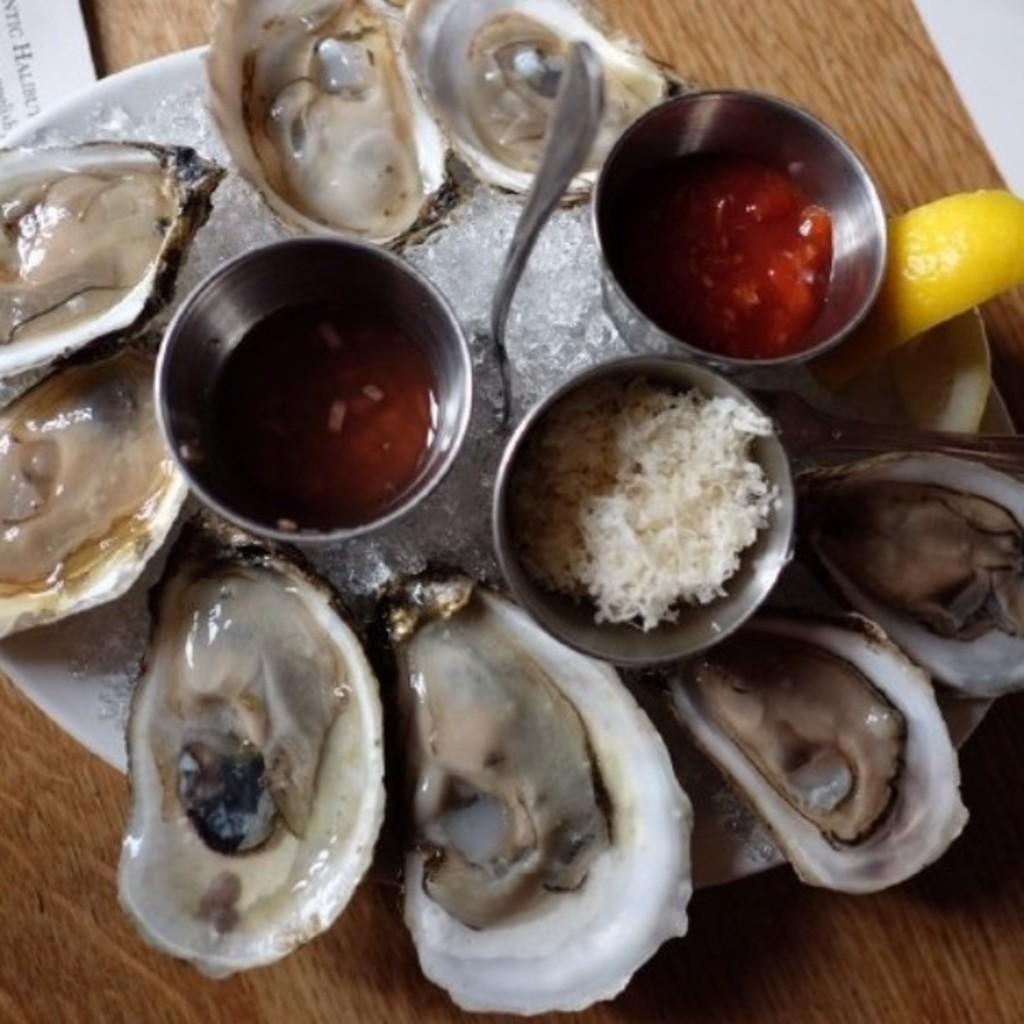Can you describe this image briefly? In the center of the image there is a table. On the table, we can see the papers, one plate, one spoon, bowls and some food items. 